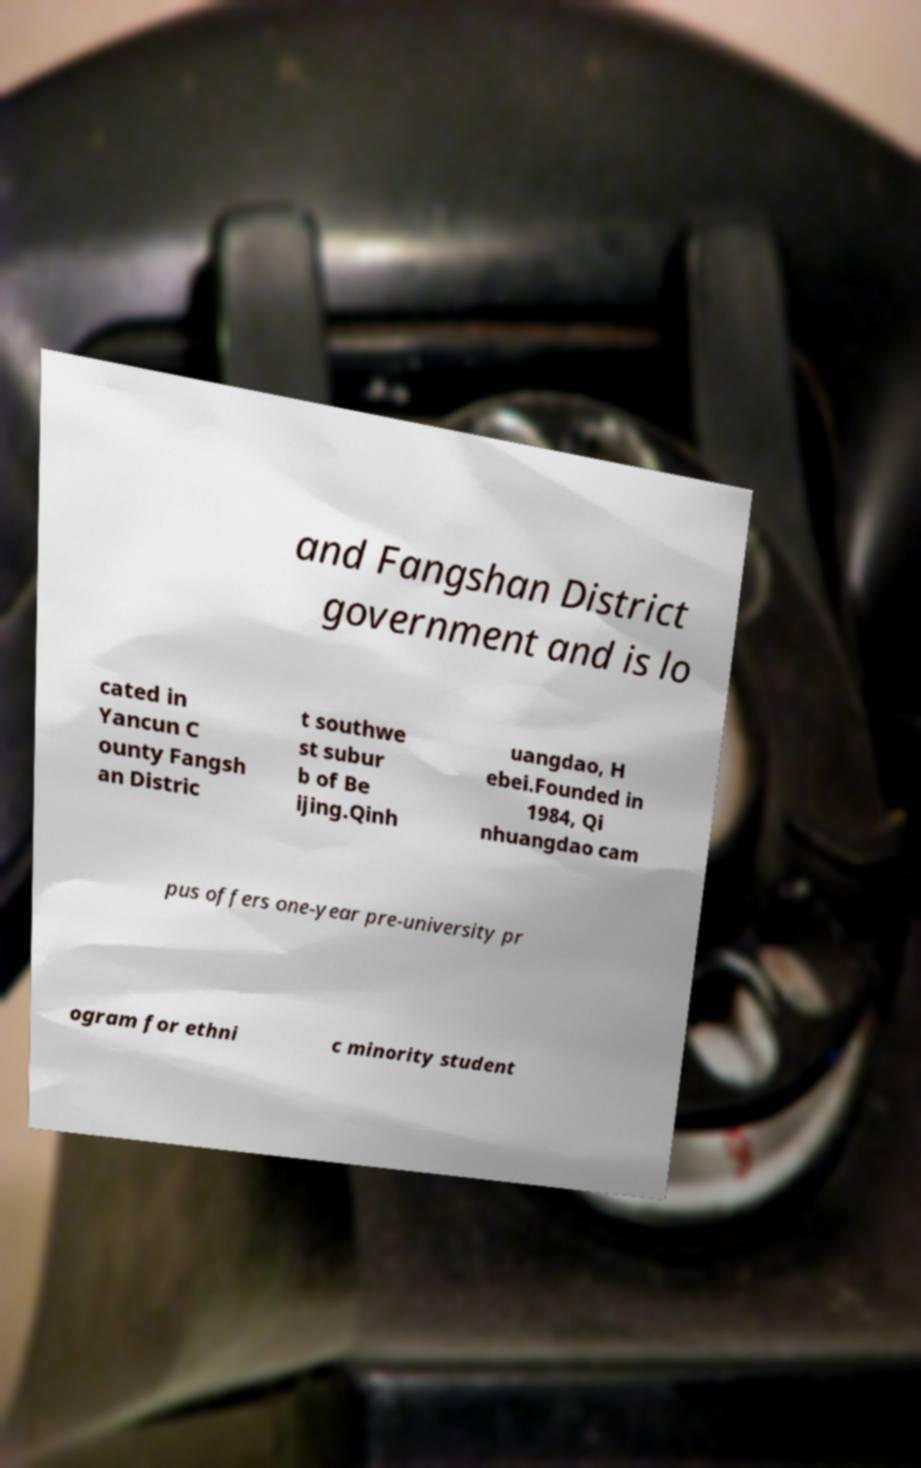What messages or text are displayed in this image? I need them in a readable, typed format. and Fangshan District government and is lo cated in Yancun C ounty Fangsh an Distric t southwe st subur b of Be ijing.Qinh uangdao, H ebei.Founded in 1984, Qi nhuangdao cam pus offers one-year pre-university pr ogram for ethni c minority student 